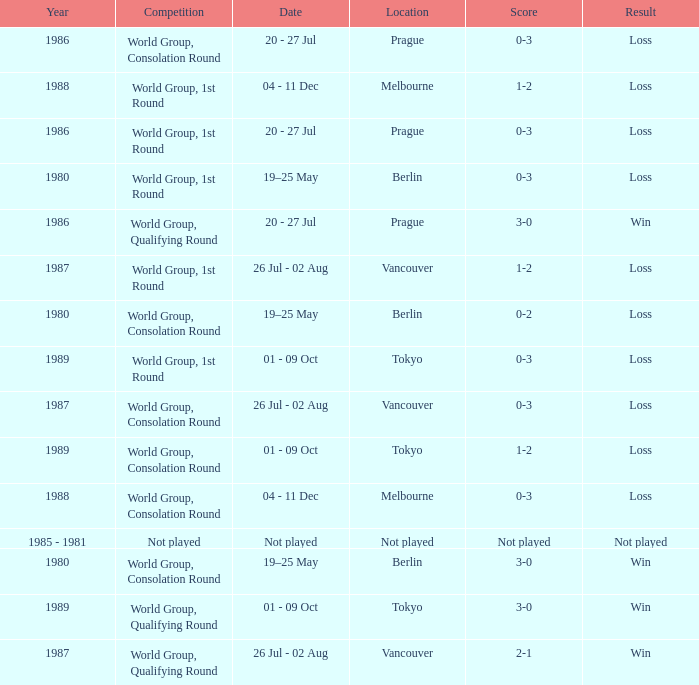What is the date for the game in prague for the world group, consolation round competition? 20 - 27 Jul. 